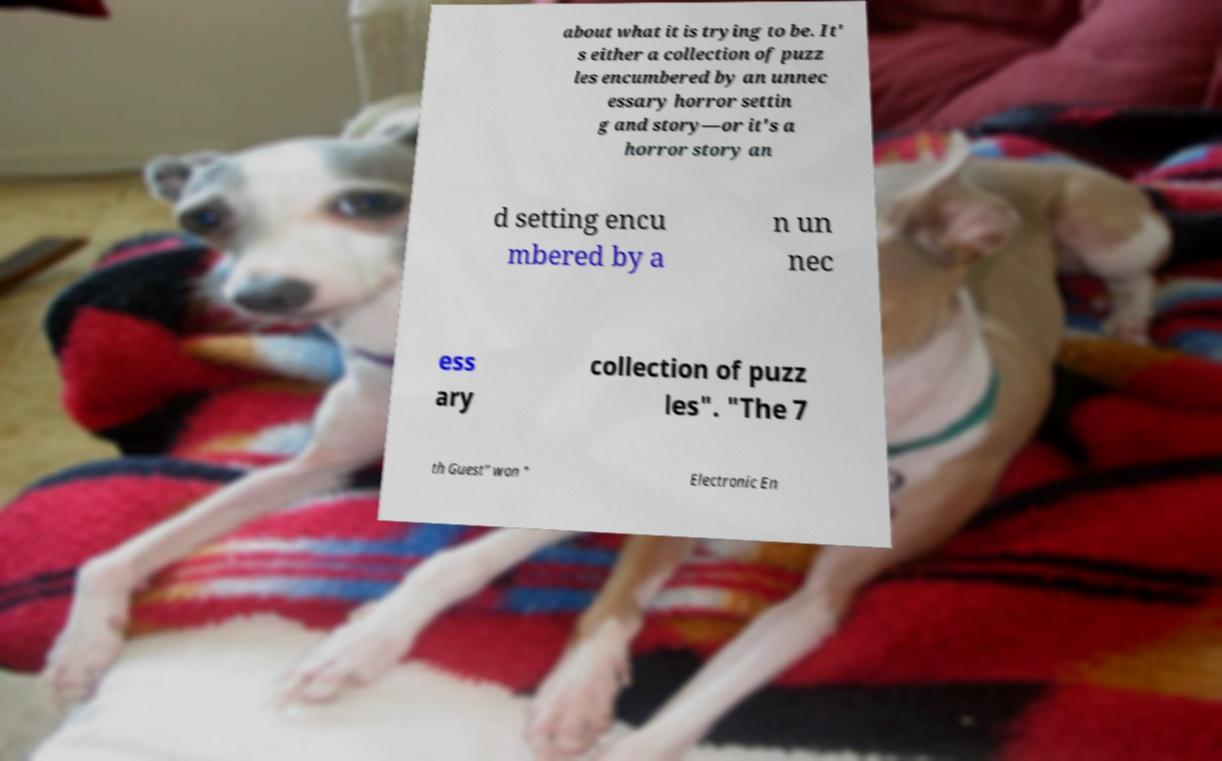Please identify and transcribe the text found in this image. about what it is trying to be. It' s either a collection of puzz les encumbered by an unnec essary horror settin g and story—or it's a horror story an d setting encu mbered by a n un nec ess ary collection of puzz les". "The 7 th Guest" won " Electronic En 